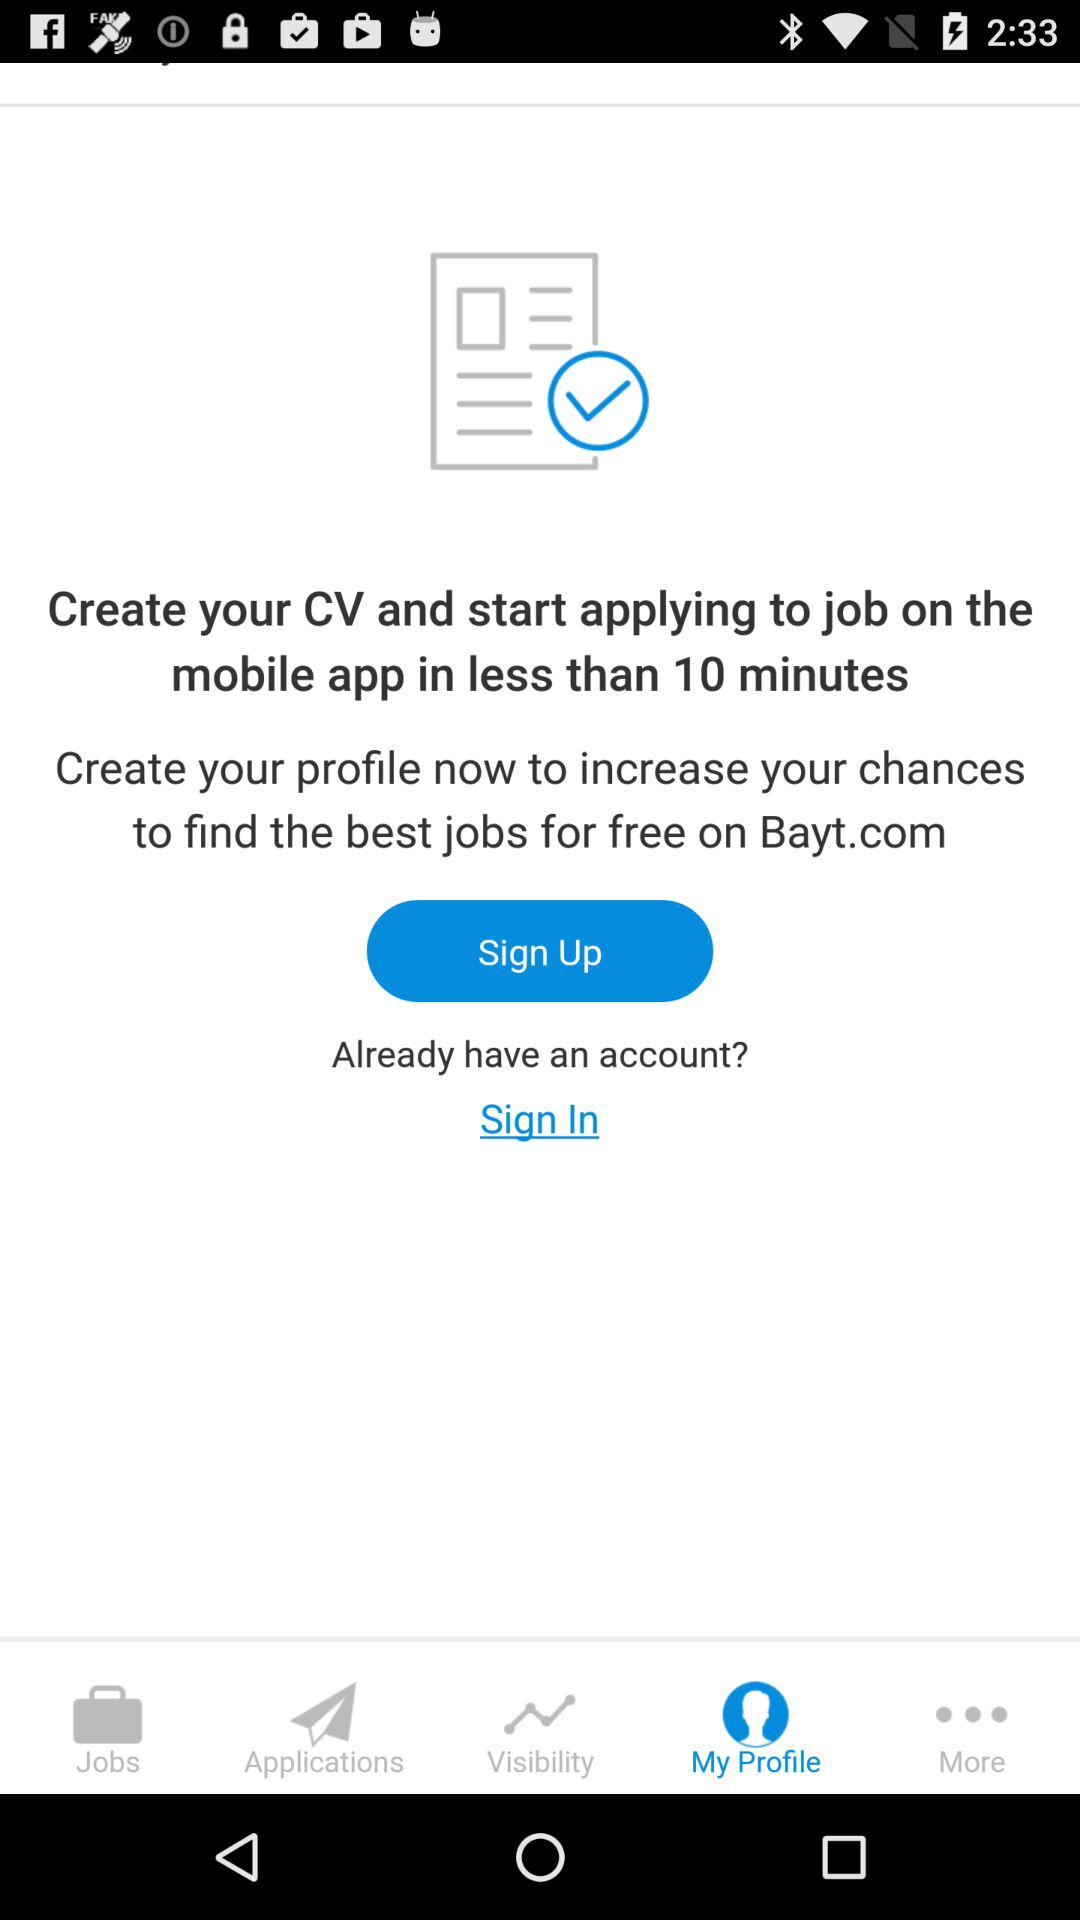Which is the selected tab? The selected tab is "My Profile". 